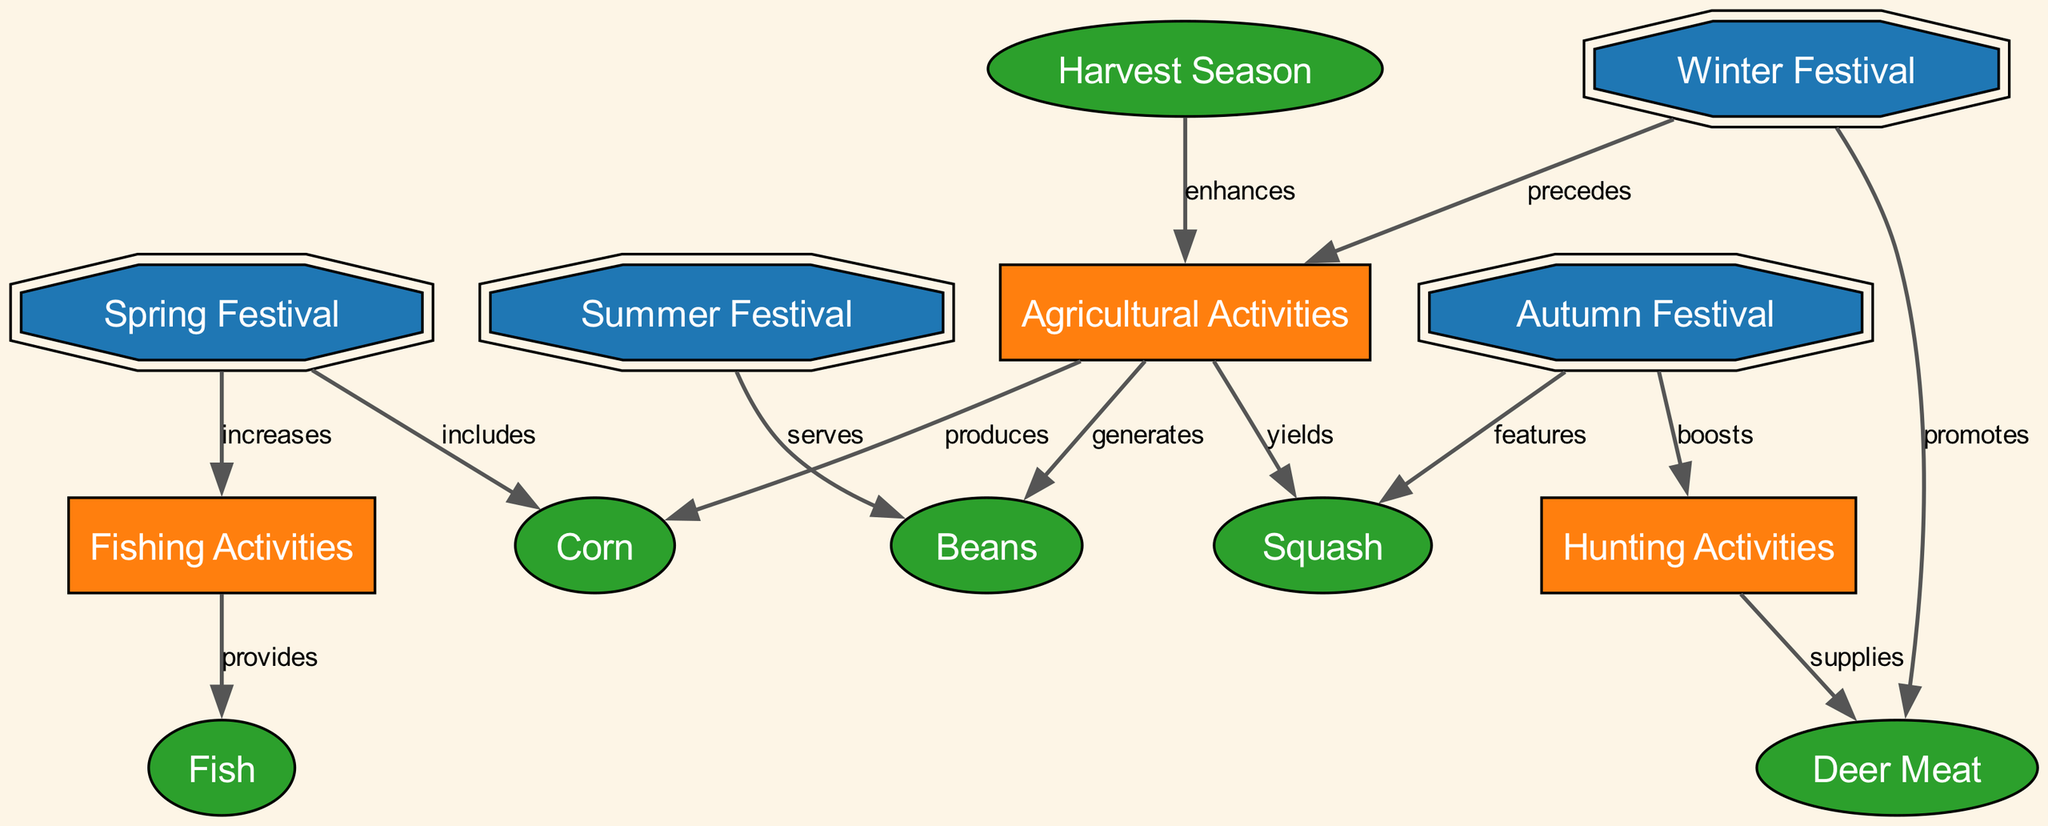What is the primary food item associated with the Spring Festival? The diagram shows that the Spring Festival includes Corn. Therefore, the primary food item associated with this festival is Corn.
Answer: Corn How many festivals are represented in the diagram? By counting the nodes labeled with 'Festival,' we find there are four: Spring Festival, Autumn Festival, Summer Festival, and Winter Festival. This results in a total of four festivals.
Answer: 4 What activity does the Autumn Festival boost? The diagram indicates that the Autumn Festival boosts Hunting Activities. Thus, the activity that is enhanced by the Autumn Festival is Hunting Activities.
Answer: Hunting Activities Which food item is served during the Summer Festival? According to the diagram, the Summer Festival serves Beans. Therefore, the food item associated with the Summer Festival is Beans.
Answer: Beans Which festival precedes Agricultural Activities? Based on the connections illustrated in the diagram, the Winter Festival precedes Agricultural Activities. Thus, the answer is the Winter Festival.
Answer: Winter Festival What food item is supplied by Hunting Activities? The diagram specifies that Hunting Activities supply Deer Meat. Therefore, the food item provided by Hunting Activities is Deer Meat.
Answer: Deer Meat How do Fishing Activities relate to Fish? The diagram shows that Fishing Activities provide Fish. This indicates a direct connection where Fishing Activities lead to the availability of Fish in the food chain.
Answer: provides What is the relationship between the Harvest Season and Agricultural Activities? The diagram explicitly states that the Harvest Season enhances Agricultural Activities. This implies that the Harvest Season plays a positive role in boosting Agricultural Activities.
Answer: enhances Which festival features Squash? It can be determined from the diagram that the Autumn Festival features Squash. Therefore, the festival that highlights this food item is the Autumn Festival.
Answer: Autumn Festival 